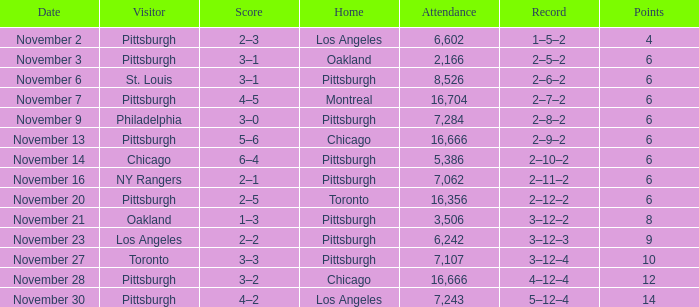What is the lowest amount of points of the game with toronto as the home team? 6.0. 